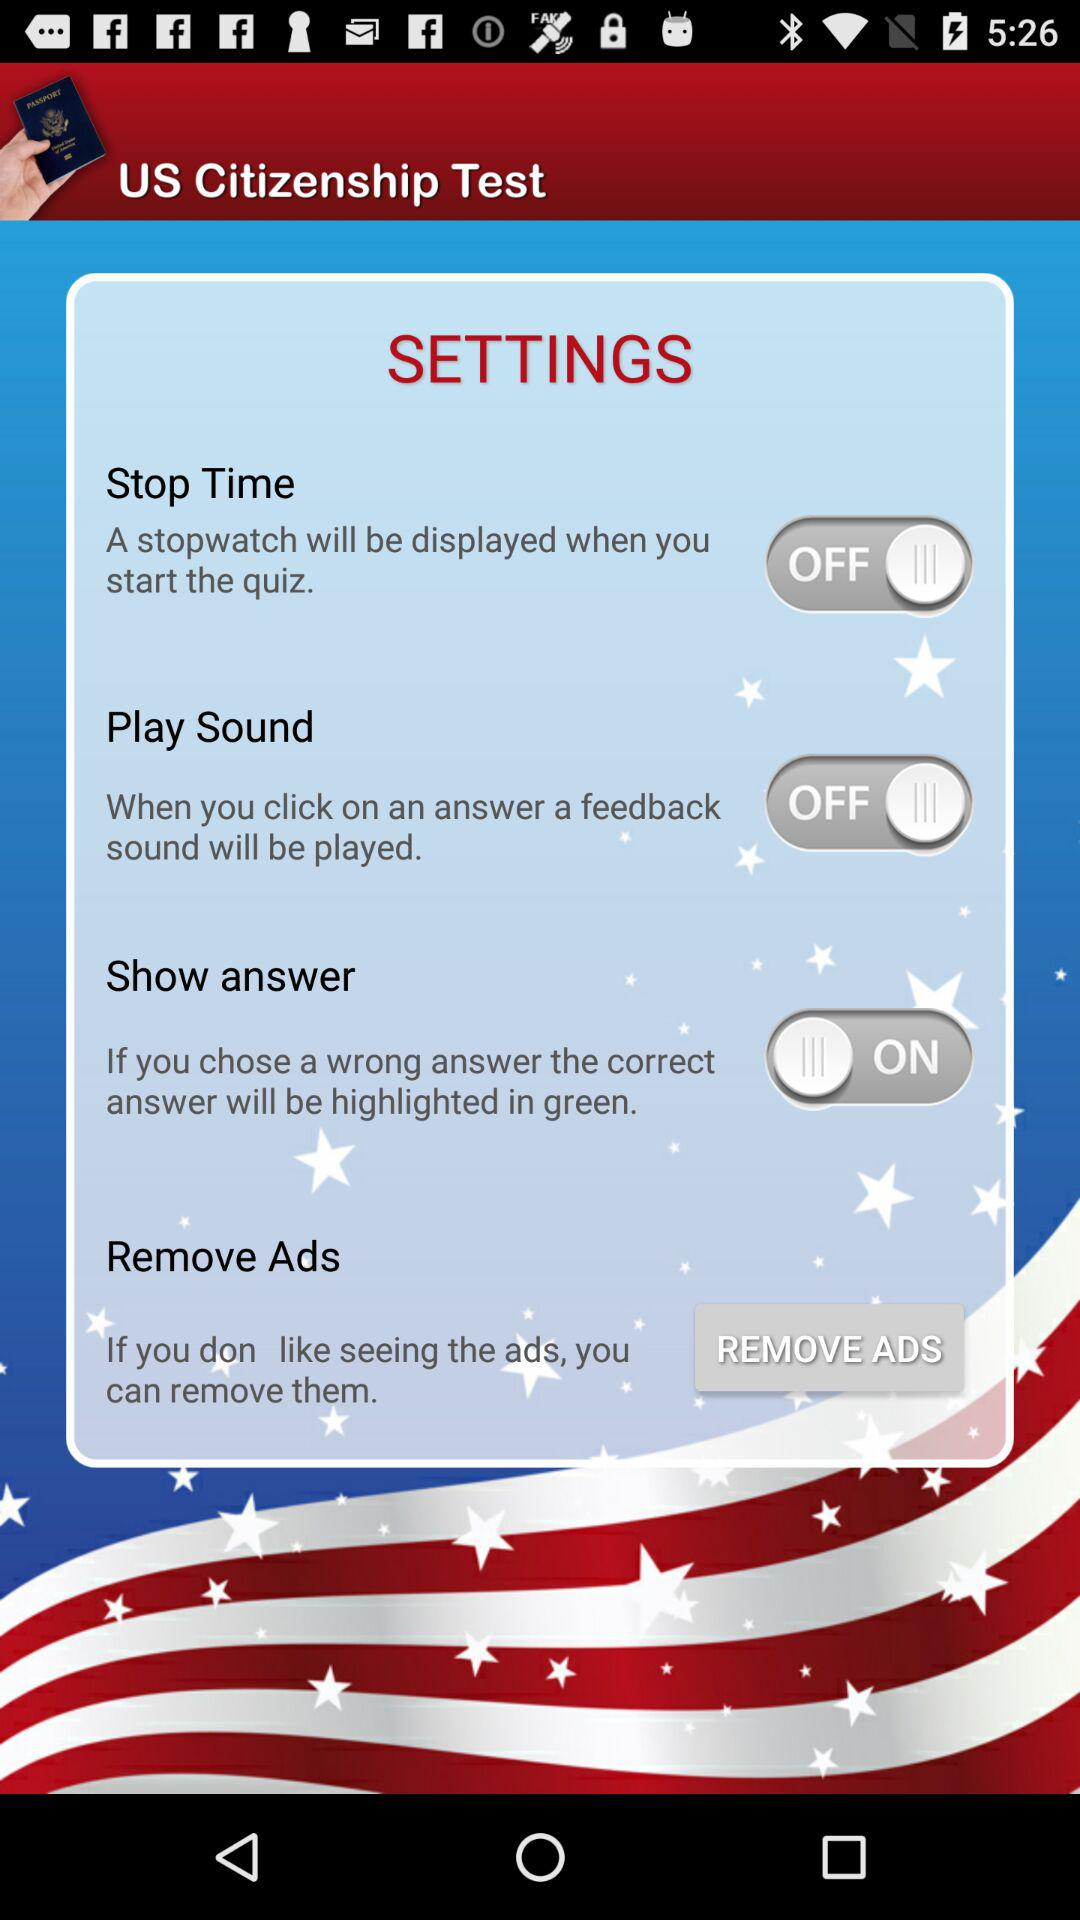How many of the settings are toggles?
Answer the question using a single word or phrase. 3 